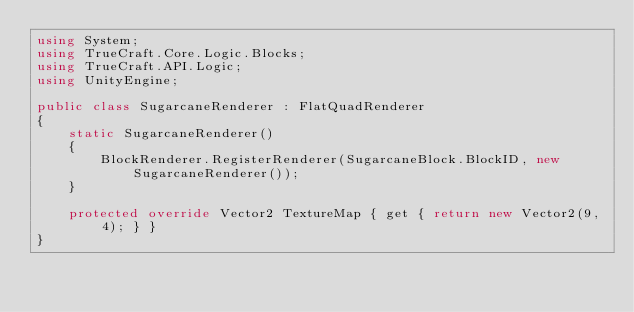<code> <loc_0><loc_0><loc_500><loc_500><_C#_>using System;
using TrueCraft.Core.Logic.Blocks;
using TrueCraft.API.Logic;
using UnityEngine;

public class SugarcaneRenderer : FlatQuadRenderer
{
    static SugarcaneRenderer()
    {
        BlockRenderer.RegisterRenderer(SugarcaneBlock.BlockID, new SugarcaneRenderer());
    }

    protected override Vector2 TextureMap { get { return new Vector2(9, 4); } }
}
</code> 